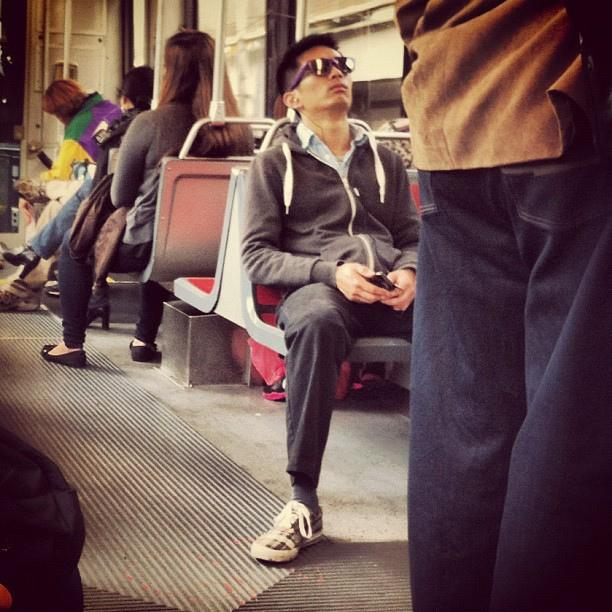How is the boy's sweater done up? Please explain your reasoning. zipper. The white thing up the middle of his jacket zips it closed. 